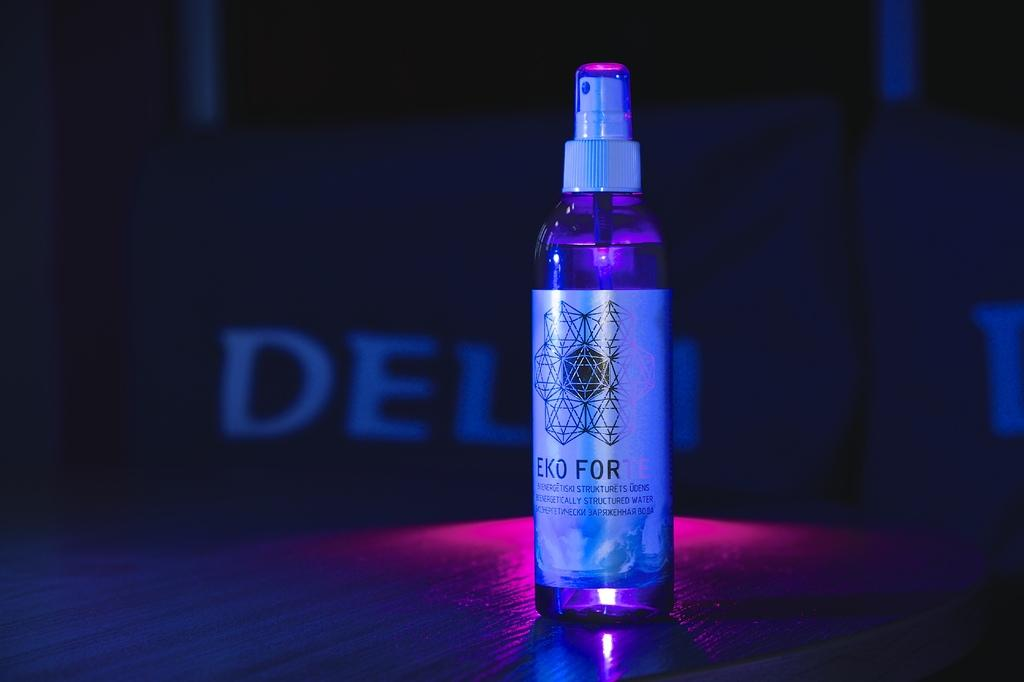<image>
Summarize the visual content of the image. A bottle with a spray top being displayed in dim lighting with label Eco For. 